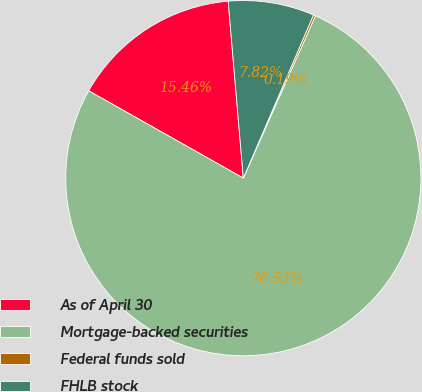Convert chart to OTSL. <chart><loc_0><loc_0><loc_500><loc_500><pie_chart><fcel>As of April 30<fcel>Mortgage-backed securities<fcel>Federal funds sold<fcel>FHLB stock<nl><fcel>15.46%<fcel>76.54%<fcel>0.19%<fcel>7.82%<nl></chart> 